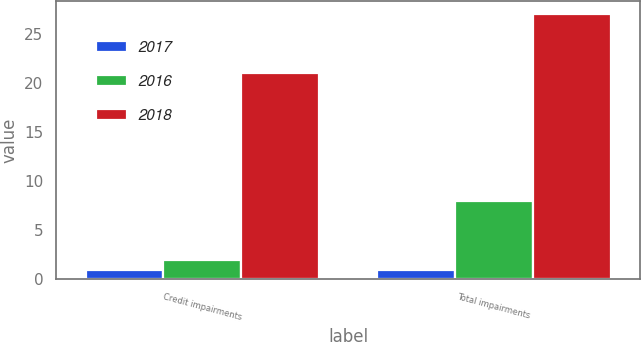<chart> <loc_0><loc_0><loc_500><loc_500><stacked_bar_chart><ecel><fcel>Credit impairments<fcel>Total impairments<nl><fcel>2017<fcel>1<fcel>1<nl><fcel>2016<fcel>2<fcel>8<nl><fcel>2018<fcel>21<fcel>27<nl></chart> 